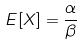Convert formula to latex. <formula><loc_0><loc_0><loc_500><loc_500>E [ X ] = \frac { \alpha } { \beta }</formula> 